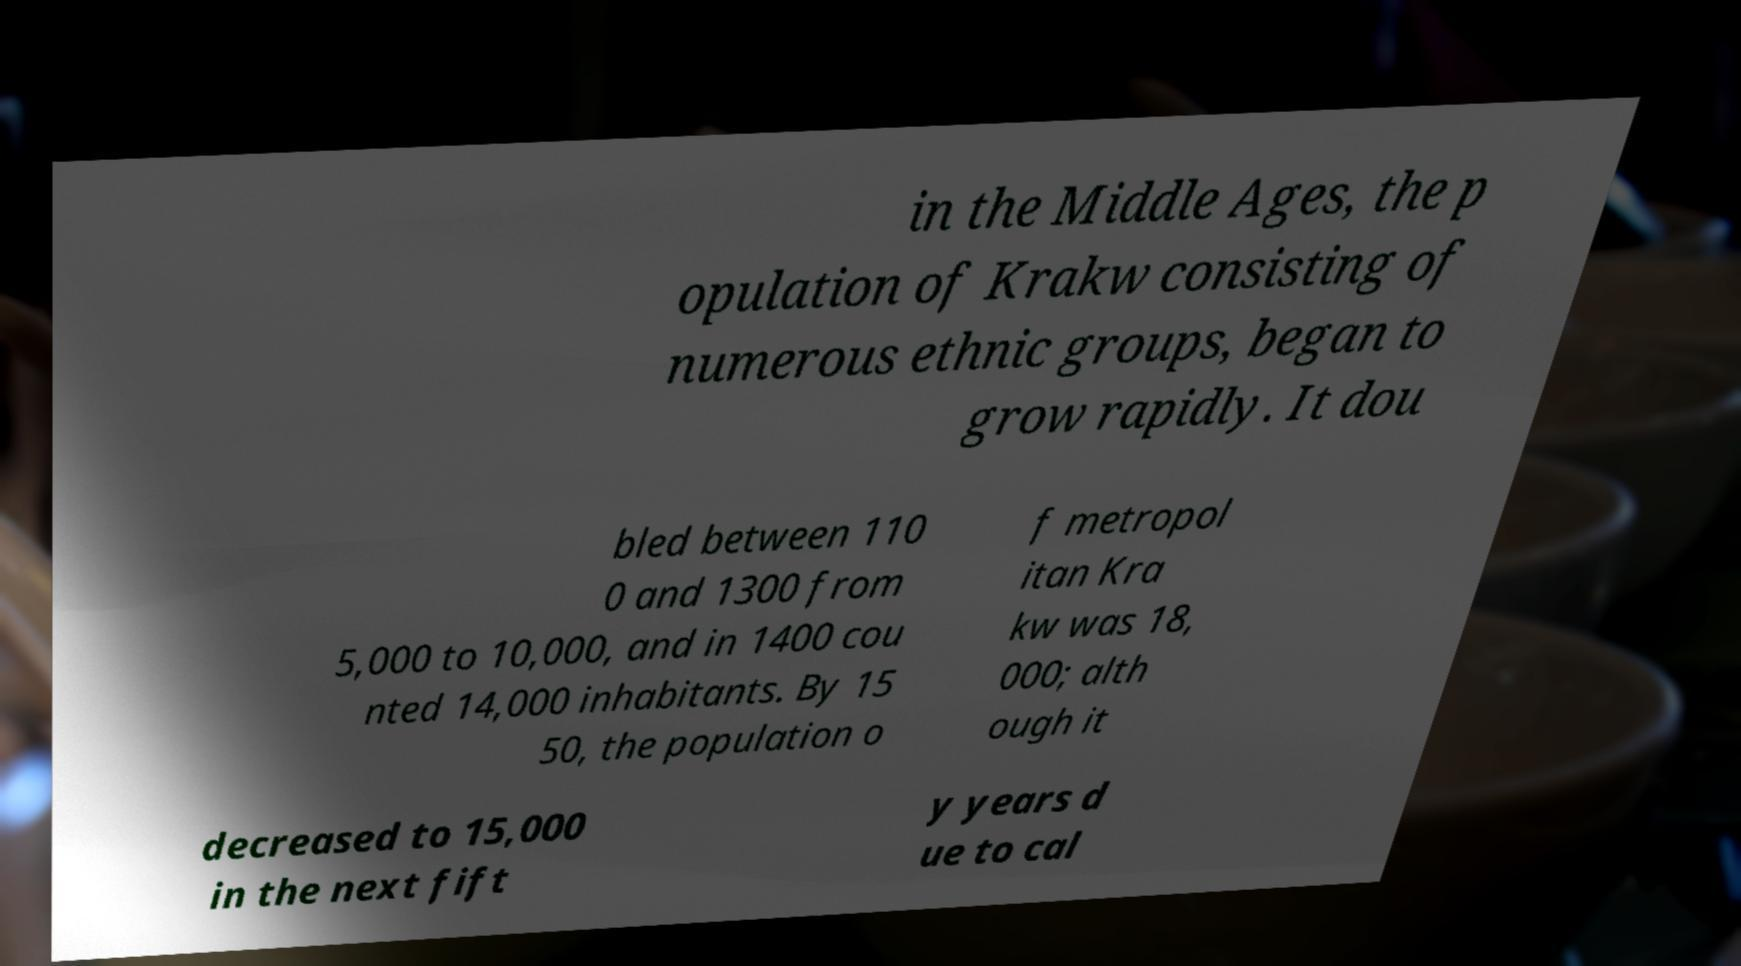What messages or text are displayed in this image? I need them in a readable, typed format. in the Middle Ages, the p opulation of Krakw consisting of numerous ethnic groups, began to grow rapidly. It dou bled between 110 0 and 1300 from 5,000 to 10,000, and in 1400 cou nted 14,000 inhabitants. By 15 50, the population o f metropol itan Kra kw was 18, 000; alth ough it decreased to 15,000 in the next fift y years d ue to cal 